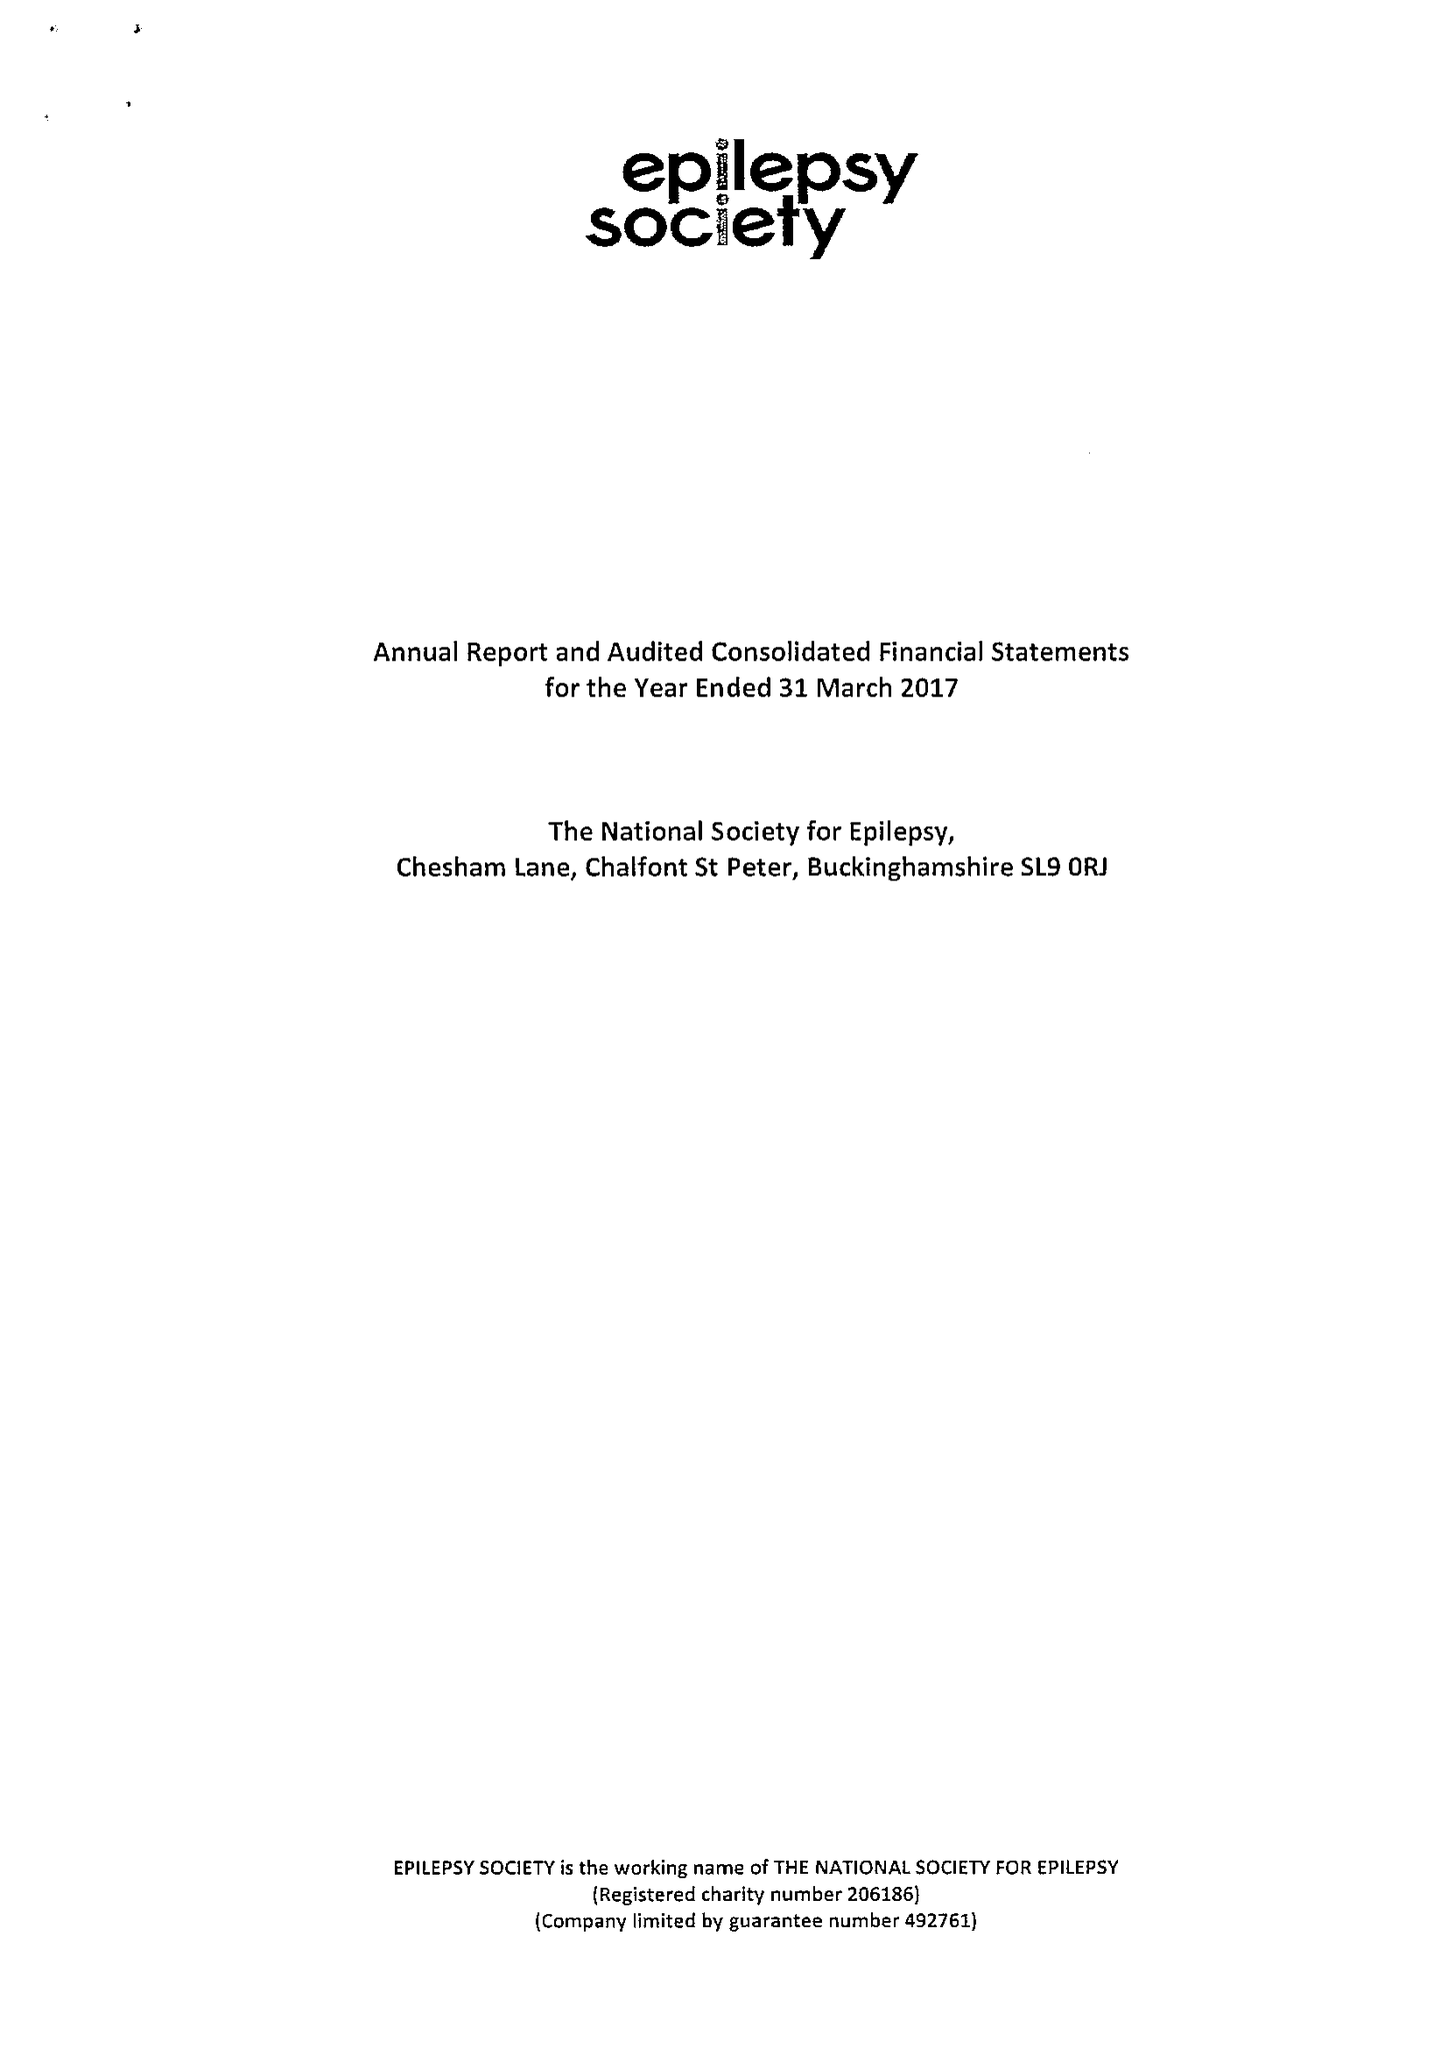What is the value for the address__postcode?
Answer the question using a single word or phrase. SL9 0RJ 